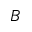<formula> <loc_0><loc_0><loc_500><loc_500>B</formula> 